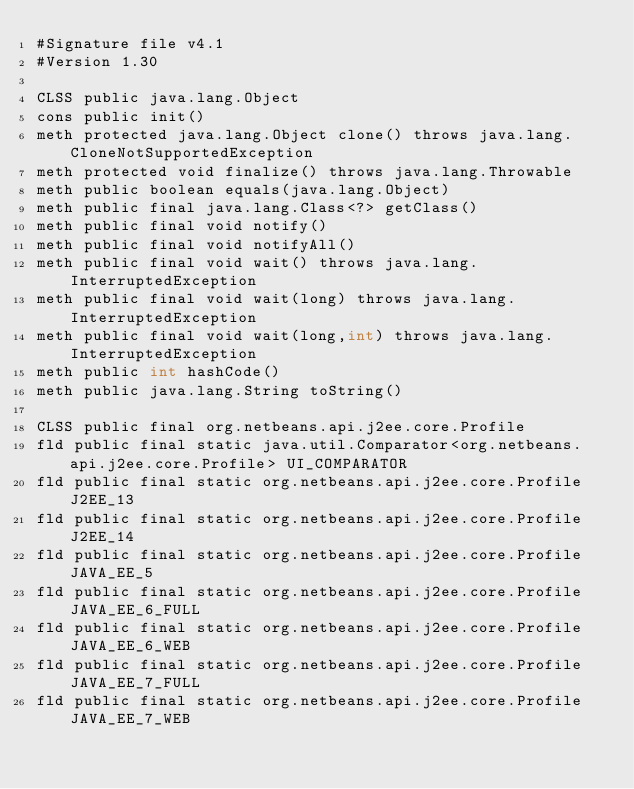<code> <loc_0><loc_0><loc_500><loc_500><_SML_>#Signature file v4.1
#Version 1.30

CLSS public java.lang.Object
cons public init()
meth protected java.lang.Object clone() throws java.lang.CloneNotSupportedException
meth protected void finalize() throws java.lang.Throwable
meth public boolean equals(java.lang.Object)
meth public final java.lang.Class<?> getClass()
meth public final void notify()
meth public final void notifyAll()
meth public final void wait() throws java.lang.InterruptedException
meth public final void wait(long) throws java.lang.InterruptedException
meth public final void wait(long,int) throws java.lang.InterruptedException
meth public int hashCode()
meth public java.lang.String toString()

CLSS public final org.netbeans.api.j2ee.core.Profile
fld public final static java.util.Comparator<org.netbeans.api.j2ee.core.Profile> UI_COMPARATOR
fld public final static org.netbeans.api.j2ee.core.Profile J2EE_13
fld public final static org.netbeans.api.j2ee.core.Profile J2EE_14
fld public final static org.netbeans.api.j2ee.core.Profile JAVA_EE_5
fld public final static org.netbeans.api.j2ee.core.Profile JAVA_EE_6_FULL
fld public final static org.netbeans.api.j2ee.core.Profile JAVA_EE_6_WEB
fld public final static org.netbeans.api.j2ee.core.Profile JAVA_EE_7_FULL
fld public final static org.netbeans.api.j2ee.core.Profile JAVA_EE_7_WEB</code> 